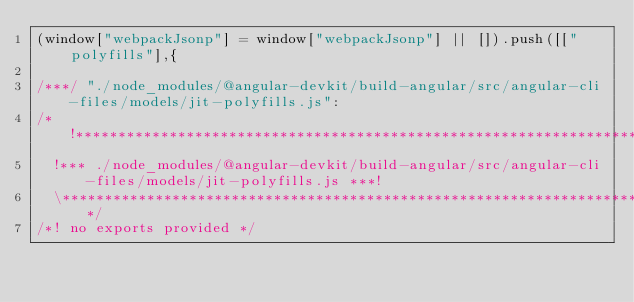<code> <loc_0><loc_0><loc_500><loc_500><_JavaScript_>(window["webpackJsonp"] = window["webpackJsonp"] || []).push([["polyfills"],{

/***/ "./node_modules/@angular-devkit/build-angular/src/angular-cli-files/models/jit-polyfills.js":
/*!**************************************************************************************************!*\
  !*** ./node_modules/@angular-devkit/build-angular/src/angular-cli-files/models/jit-polyfills.js ***!
  \**************************************************************************************************/
/*! no exports provided */</code> 